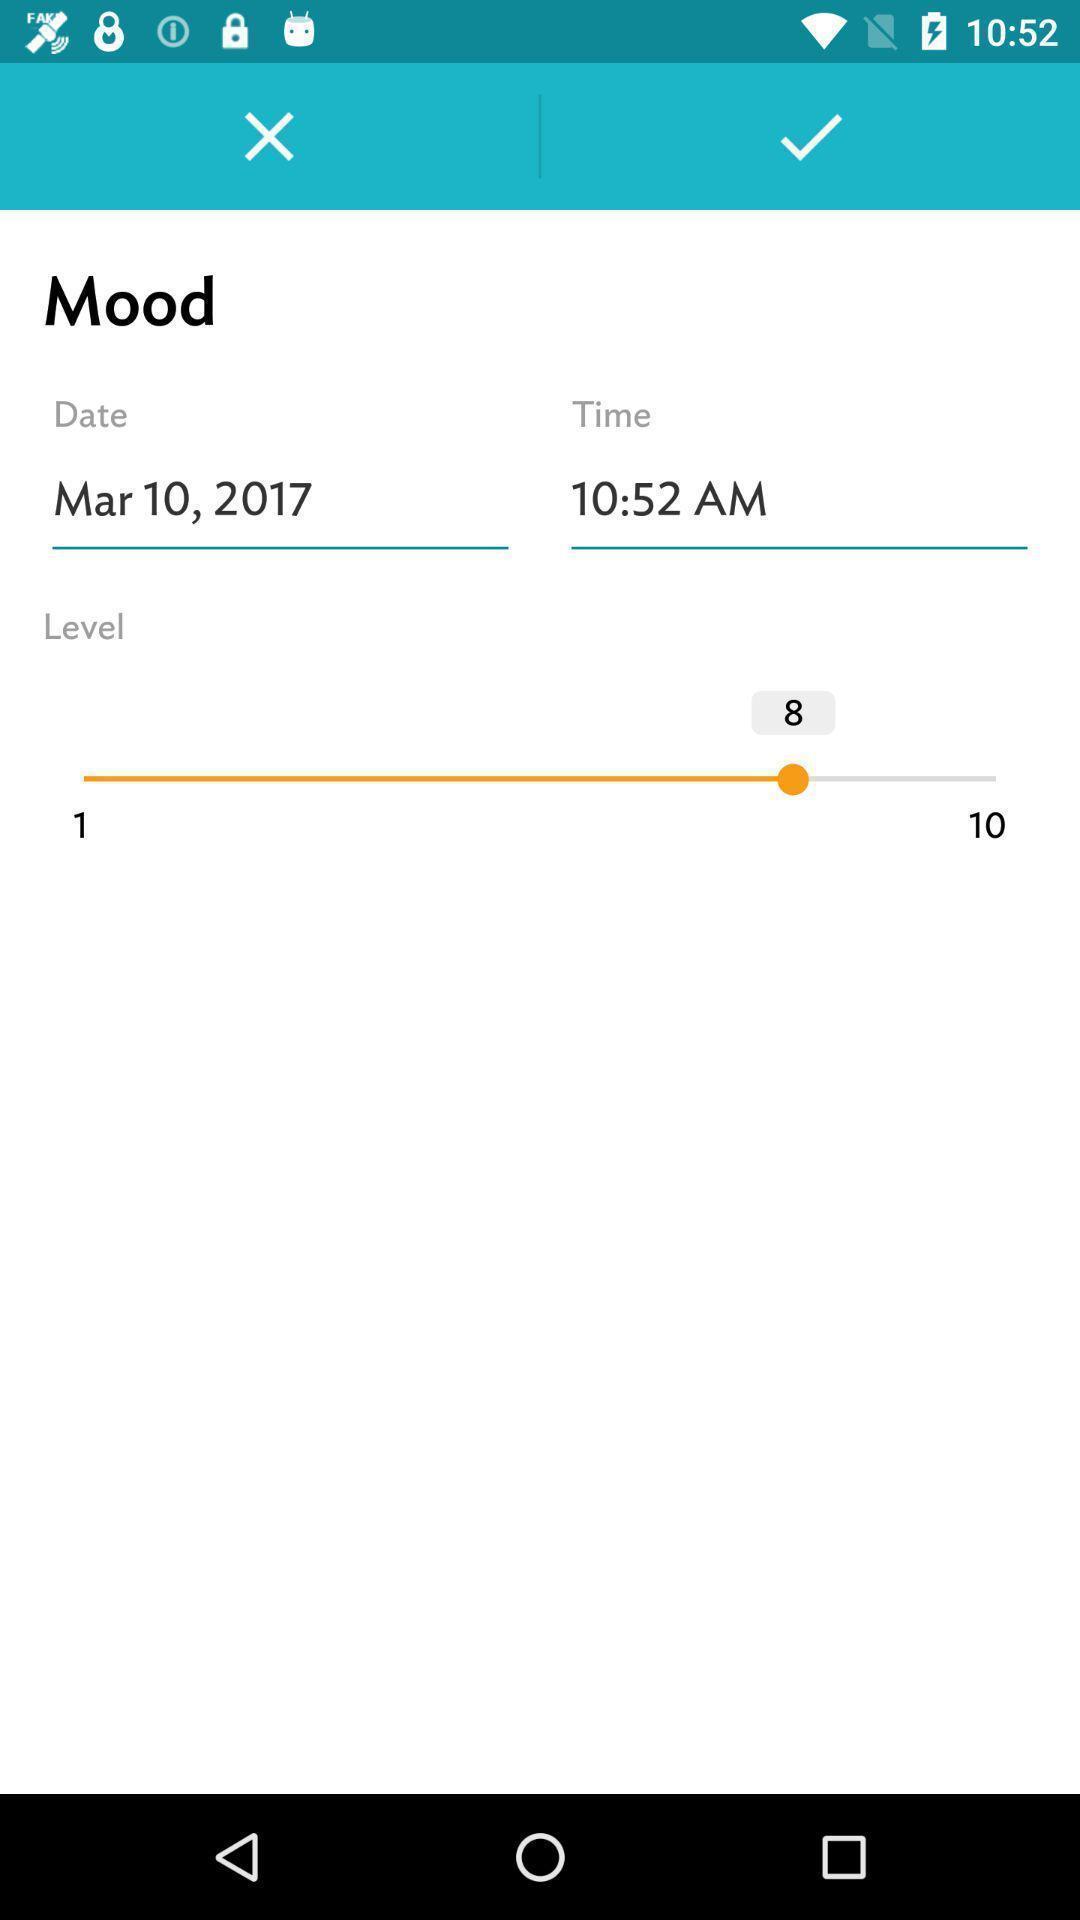Provide a detailed account of this screenshot. Page showing options to set a mood time and date. 